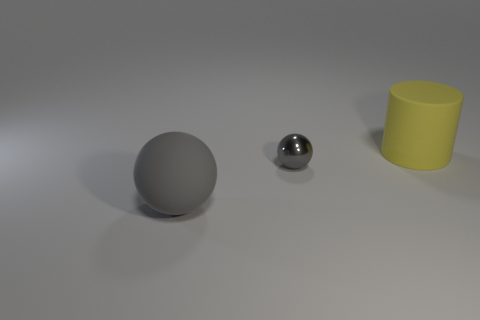The shiny object that is the same color as the large ball is what shape?
Make the answer very short. Sphere. How many spheres are either tiny rubber objects or big gray things?
Your response must be concise. 1. How many other gray spheres have the same material as the big gray sphere?
Ensure brevity in your answer.  0. Is the material of the thing that is behind the tiny gray thing the same as the gray sphere that is to the left of the small sphere?
Ensure brevity in your answer.  Yes. There is a small gray metallic object that is on the left side of the large rubber object behind the rubber sphere; what number of large yellow rubber cylinders are in front of it?
Your answer should be compact. 0. There is a large rubber sphere in front of the small gray shiny sphere; is its color the same as the big thing that is right of the large gray sphere?
Give a very brief answer. No. Are there any other things that are the same color as the large cylinder?
Give a very brief answer. No. The rubber thing to the right of the large matte thing in front of the yellow matte object is what color?
Give a very brief answer. Yellow. Are there any rubber objects?
Offer a very short reply. Yes. There is a thing that is on the left side of the big yellow cylinder and to the right of the matte sphere; what color is it?
Make the answer very short. Gray. 